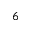Convert formula to latex. <formula><loc_0><loc_0><loc_500><loc_500>^ { 6 }</formula> 